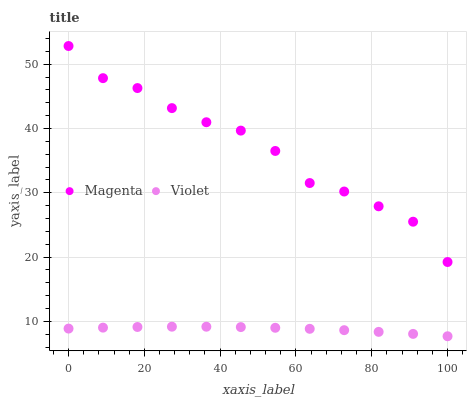Does Violet have the minimum area under the curve?
Answer yes or no. Yes. Does Magenta have the maximum area under the curve?
Answer yes or no. Yes. Does Violet have the maximum area under the curve?
Answer yes or no. No. Is Violet the smoothest?
Answer yes or no. Yes. Is Magenta the roughest?
Answer yes or no. Yes. Is Violet the roughest?
Answer yes or no. No. Does Violet have the lowest value?
Answer yes or no. Yes. Does Magenta have the highest value?
Answer yes or no. Yes. Does Violet have the highest value?
Answer yes or no. No. Is Violet less than Magenta?
Answer yes or no. Yes. Is Magenta greater than Violet?
Answer yes or no. Yes. Does Violet intersect Magenta?
Answer yes or no. No. 